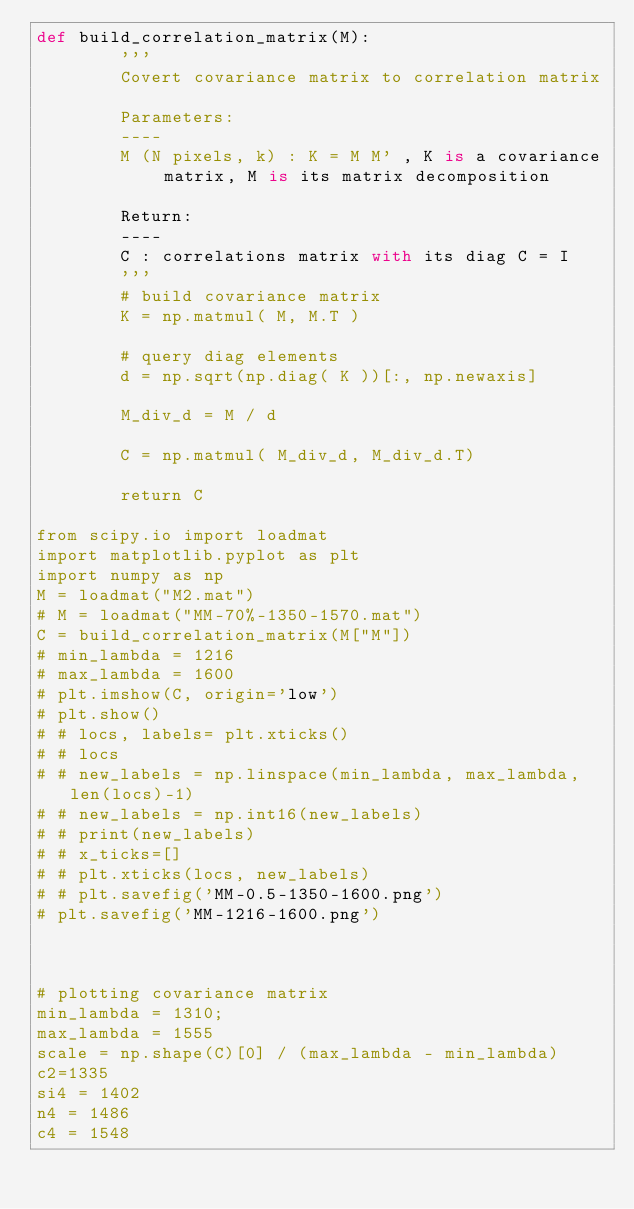<code> <loc_0><loc_0><loc_500><loc_500><_Python_>def build_correlation_matrix(M):
        '''
        Covert covariance matrix to correlation matrix

        Parameters:
        ----
        M (N pixels, k) : K = M M' , K is a covariance matrix, M is its matrix decomposition   

        Return:
        ----
        C : correlations matrix with its diag C = I
        '''
        # build covariance matrix
        K = np.matmul( M, M.T )

        # query diag elements
        d = np.sqrt(np.diag( K ))[:, np.newaxis]
        
        M_div_d = M / d

        C = np.matmul( M_div_d, M_div_d.T)

        return C

from scipy.io import loadmat                                                                            
import matplotlib.pyplot as plt
import numpy as np
M = loadmat("M2.mat")                                                                                   
# M = loadmat("MM-70%-1350-1570.mat")                                                                                   
C = build_correlation_matrix(M["M"])    
# min_lambda = 1216
# max_lambda = 1600
# plt.imshow(C, origin='low')
# plt.show()
# # locs, labels= plt.xticks()
# # locs
# # new_labels = np.linspace(min_lambda, max_lambda,len(locs)-1)
# # new_labels = np.int16(new_labels)
# # print(new_labels)
# # x_ticks=[]
# # plt.xticks(locs, new_labels)
# # plt.savefig('MM-0.5-1350-1600.png')
# plt.savefig('MM-1216-1600.png')



# plotting covariance matrix
min_lambda = 1310;          
max_lambda = 1555
scale = np.shape(C)[0] / (max_lambda - min_lambda)
c2=1335
si4 = 1402
n4 = 1486
c4 = 1548</code> 